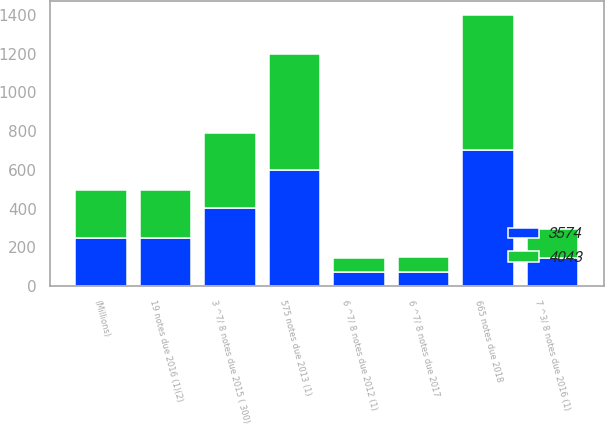Convert chart to OTSL. <chart><loc_0><loc_0><loc_500><loc_500><stacked_bar_chart><ecel><fcel>(Millions)<fcel>6 ^7/ 8 notes due 2012 (1)<fcel>575 notes due 2013 (1)<fcel>3 ^7/ 8 notes due 2015 ( 300)<fcel>19 notes due 2016 (1)(2)<fcel>7 ^3/ 8 notes due 2016 (1)<fcel>6 ^7/ 8 notes due 2017<fcel>665 notes due 2018<nl><fcel>4043<fcel>248<fcel>71<fcel>600<fcel>388<fcel>248<fcel>146<fcel>74<fcel>700<nl><fcel>3574<fcel>248<fcel>71<fcel>600<fcel>401<fcel>248<fcel>146<fcel>74<fcel>700<nl></chart> 